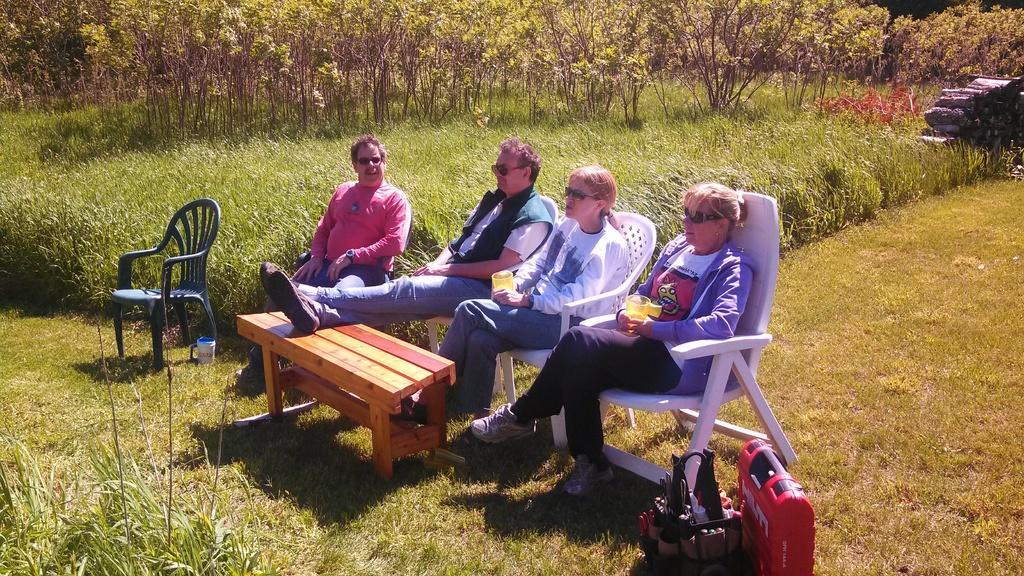Could you give a brief overview of what you see in this image? In this picture there are four people who are sitting on the chair. There is a cup, a table , a bag. There are few trees ,logs and some grass. There is a jug. 